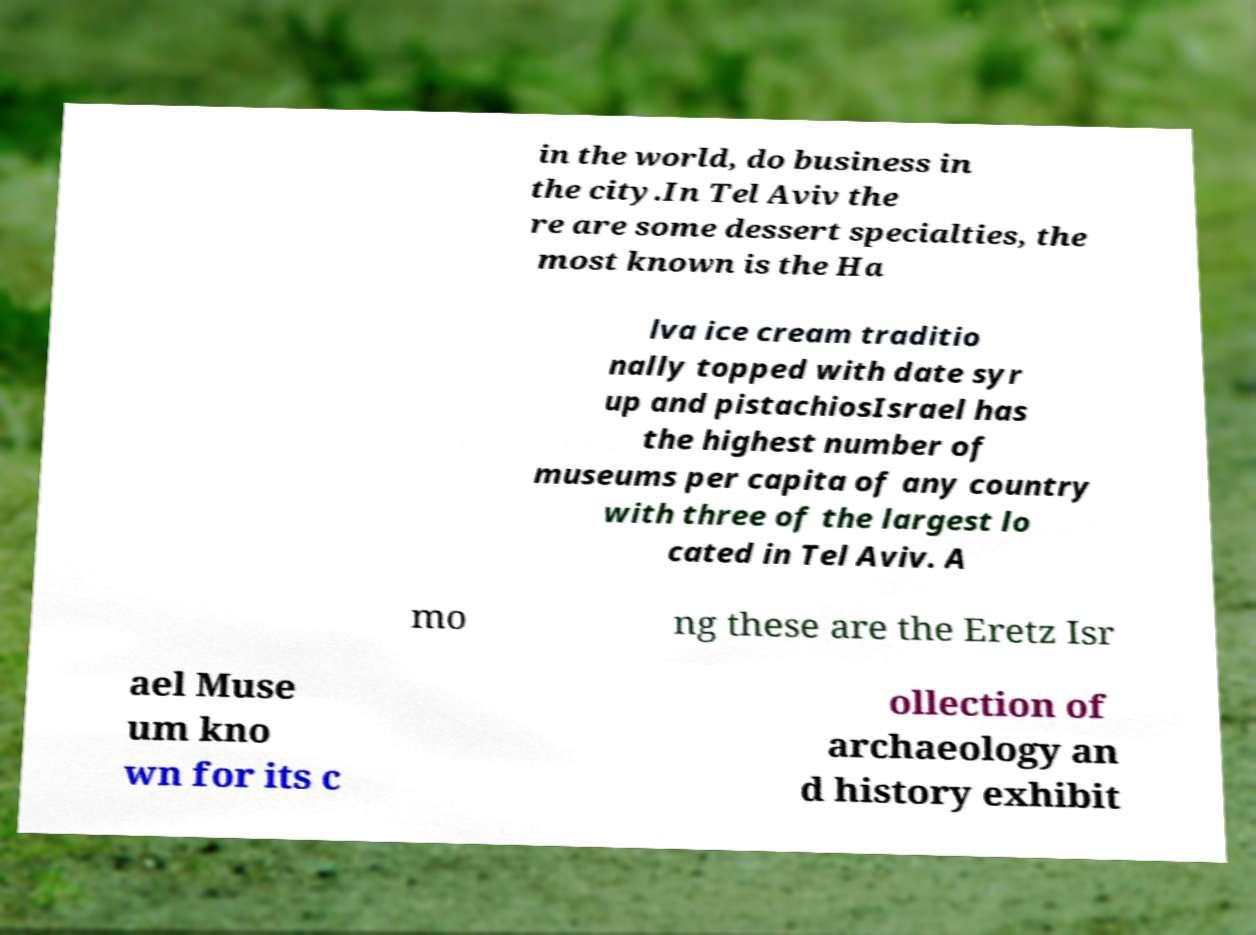Could you extract and type out the text from this image? in the world, do business in the city.In Tel Aviv the re are some dessert specialties, the most known is the Ha lva ice cream traditio nally topped with date syr up and pistachiosIsrael has the highest number of museums per capita of any country with three of the largest lo cated in Tel Aviv. A mo ng these are the Eretz Isr ael Muse um kno wn for its c ollection of archaeology an d history exhibit 